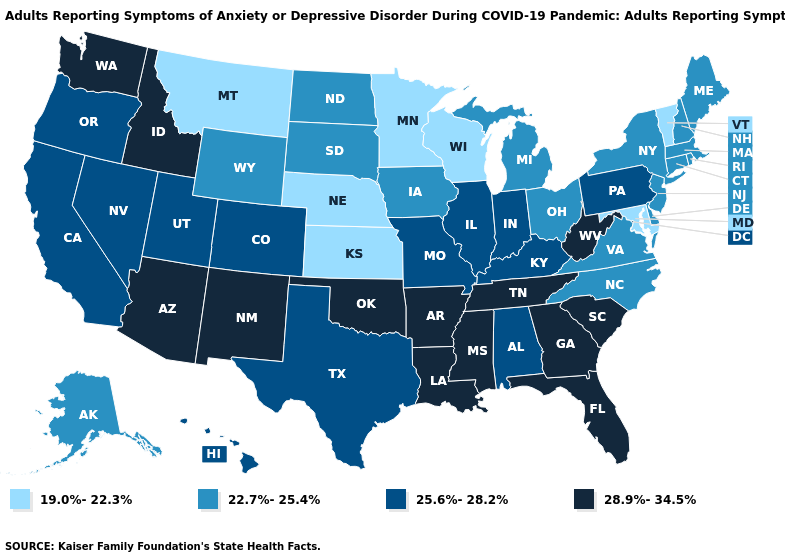Does Washington have the highest value in the West?
Write a very short answer. Yes. Does Alaska have the same value as Illinois?
Be succinct. No. Does Montana have the lowest value in the West?
Be succinct. Yes. Among the states that border Louisiana , which have the highest value?
Concise answer only. Arkansas, Mississippi. What is the lowest value in the USA?
Give a very brief answer. 19.0%-22.3%. Does the map have missing data?
Short answer required. No. Name the states that have a value in the range 22.7%-25.4%?
Keep it brief. Alaska, Connecticut, Delaware, Iowa, Maine, Massachusetts, Michigan, New Hampshire, New Jersey, New York, North Carolina, North Dakota, Ohio, Rhode Island, South Dakota, Virginia, Wyoming. Which states hav the highest value in the Northeast?
Give a very brief answer. Pennsylvania. Does the map have missing data?
Be succinct. No. What is the value of New Hampshire?
Write a very short answer. 22.7%-25.4%. Does Ohio have the same value as New Jersey?
Concise answer only. Yes. Among the states that border Ohio , does Indiana have the highest value?
Answer briefly. No. Is the legend a continuous bar?
Keep it brief. No. Does Oklahoma have the highest value in the South?
Keep it brief. Yes. What is the value of Oregon?
Concise answer only. 25.6%-28.2%. 